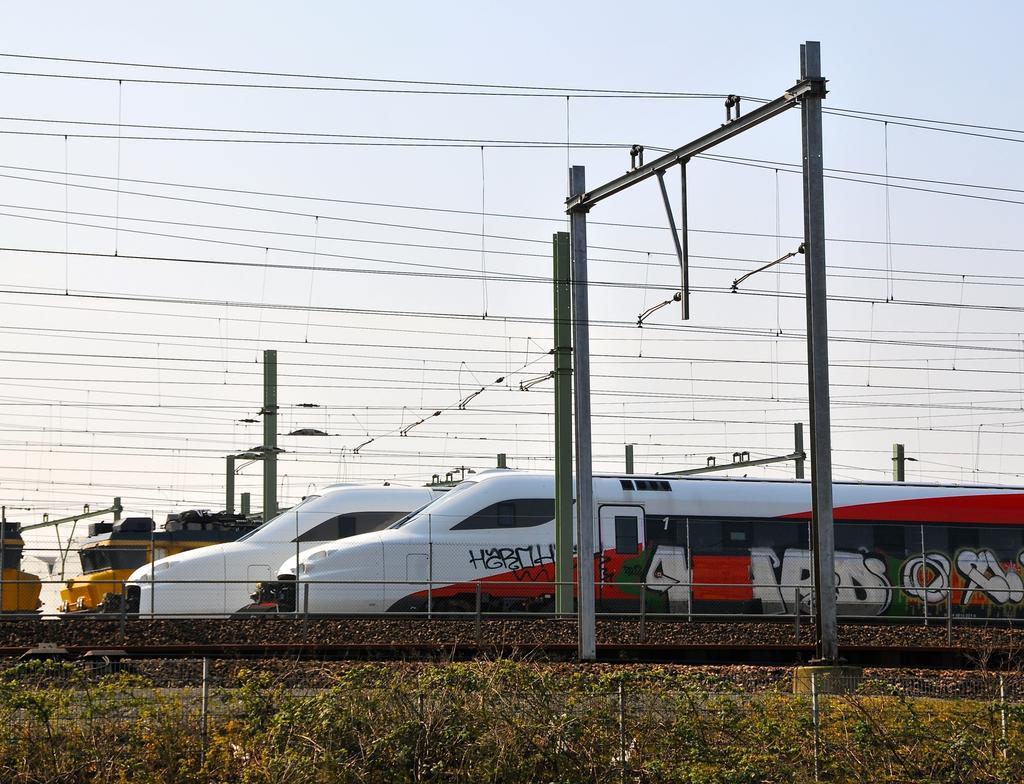How would you summarize this image in a sentence or two? In the image we can see the trains on the train tracks. Here we can see electric poles and electric wires. Here we can see the fence and the sky.  